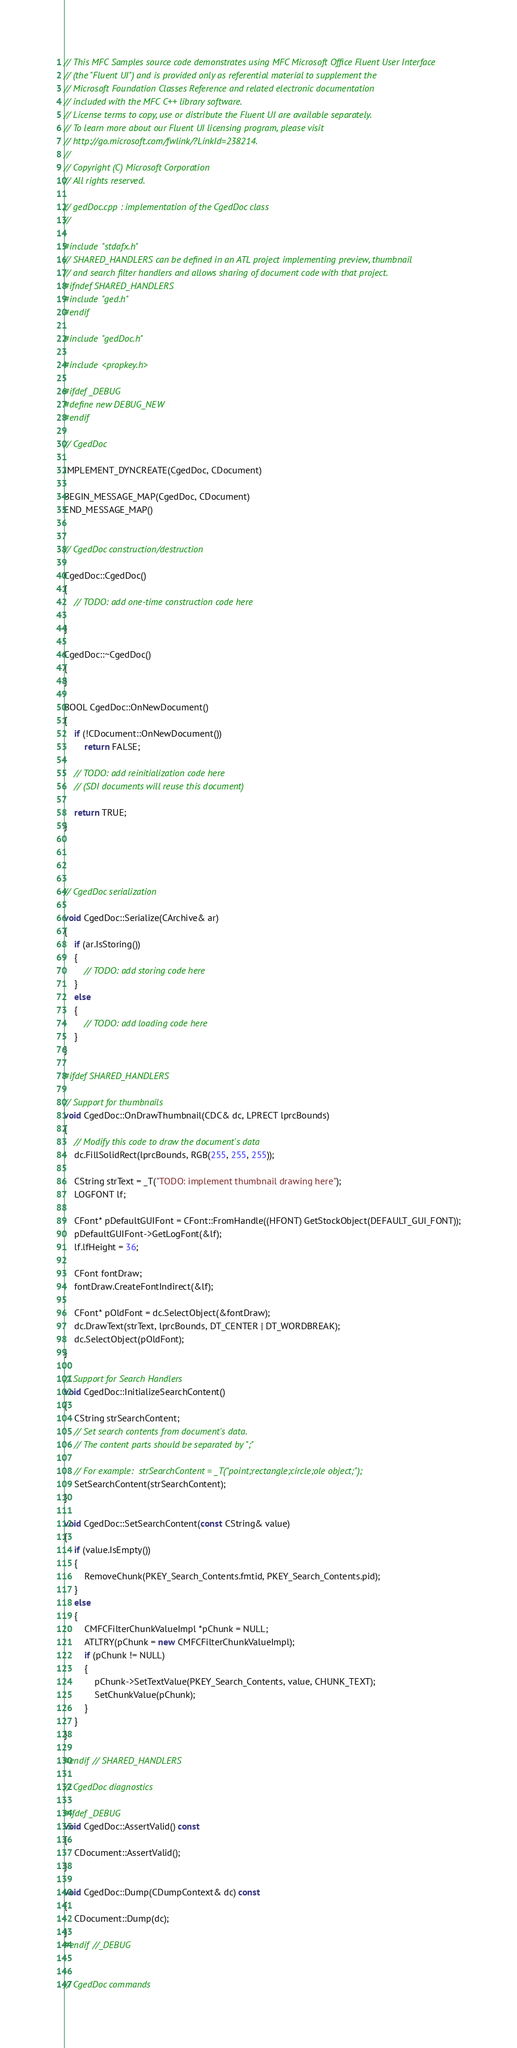Convert code to text. <code><loc_0><loc_0><loc_500><loc_500><_C++_>// This MFC Samples source code demonstrates using MFC Microsoft Office Fluent User Interface 
// (the "Fluent UI") and is provided only as referential material to supplement the 
// Microsoft Foundation Classes Reference and related electronic documentation 
// included with the MFC C++ library software.  
// License terms to copy, use or distribute the Fluent UI are available separately.  
// To learn more about our Fluent UI licensing program, please visit 
// http://go.microsoft.com/fwlink/?LinkId=238214.
//
// Copyright (C) Microsoft Corporation
// All rights reserved.

// gedDoc.cpp : implementation of the CgedDoc class
//

#include "stdafx.h"
// SHARED_HANDLERS can be defined in an ATL project implementing preview, thumbnail
// and search filter handlers and allows sharing of document code with that project.
#ifndef SHARED_HANDLERS
#include "ged.h"
#endif

#include "gedDoc.h"

#include <propkey.h>

#ifdef _DEBUG
#define new DEBUG_NEW
#endif

// CgedDoc

IMPLEMENT_DYNCREATE(CgedDoc, CDocument)

BEGIN_MESSAGE_MAP(CgedDoc, CDocument)
END_MESSAGE_MAP()


// CgedDoc construction/destruction

CgedDoc::CgedDoc()
{
	// TODO: add one-time construction code here

}

CgedDoc::~CgedDoc()
{
}

BOOL CgedDoc::OnNewDocument()
{
	if (!CDocument::OnNewDocument())
		return FALSE;

	// TODO: add reinitialization code here
	// (SDI documents will reuse this document)

	return TRUE;
}




// CgedDoc serialization

void CgedDoc::Serialize(CArchive& ar)
{
	if (ar.IsStoring())
	{
		// TODO: add storing code here
	}
	else
	{
		// TODO: add loading code here
	}
}

#ifdef SHARED_HANDLERS

// Support for thumbnails
void CgedDoc::OnDrawThumbnail(CDC& dc, LPRECT lprcBounds)
{
	// Modify this code to draw the document's data
	dc.FillSolidRect(lprcBounds, RGB(255, 255, 255));

	CString strText = _T("TODO: implement thumbnail drawing here");
	LOGFONT lf;

	CFont* pDefaultGUIFont = CFont::FromHandle((HFONT) GetStockObject(DEFAULT_GUI_FONT));
	pDefaultGUIFont->GetLogFont(&lf);
	lf.lfHeight = 36;

	CFont fontDraw;
	fontDraw.CreateFontIndirect(&lf);

	CFont* pOldFont = dc.SelectObject(&fontDraw);
	dc.DrawText(strText, lprcBounds, DT_CENTER | DT_WORDBREAK);
	dc.SelectObject(pOldFont);
}

// Support for Search Handlers
void CgedDoc::InitializeSearchContent()
{
	CString strSearchContent;
	// Set search contents from document's data. 
	// The content parts should be separated by ";"

	// For example:  strSearchContent = _T("point;rectangle;circle;ole object;");
	SetSearchContent(strSearchContent);
}

void CgedDoc::SetSearchContent(const CString& value)
{
	if (value.IsEmpty())
	{
		RemoveChunk(PKEY_Search_Contents.fmtid, PKEY_Search_Contents.pid);
	}
	else
	{
		CMFCFilterChunkValueImpl *pChunk = NULL;
		ATLTRY(pChunk = new CMFCFilterChunkValueImpl);
		if (pChunk != NULL)
		{
			pChunk->SetTextValue(PKEY_Search_Contents, value, CHUNK_TEXT);
			SetChunkValue(pChunk);
		}
	}
}

#endif // SHARED_HANDLERS

// CgedDoc diagnostics

#ifdef _DEBUG
void CgedDoc::AssertValid() const
{
	CDocument::AssertValid();
}

void CgedDoc::Dump(CDumpContext& dc) const
{
	CDocument::Dump(dc);
}
#endif //_DEBUG


// CgedDoc commands
</code> 